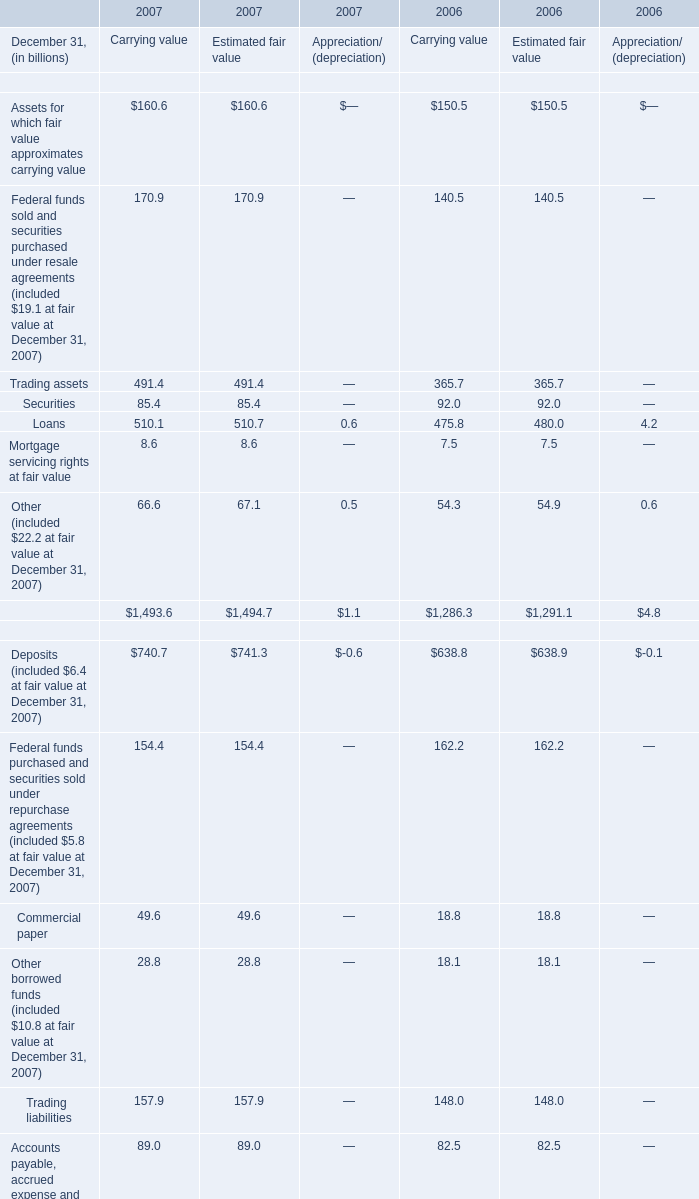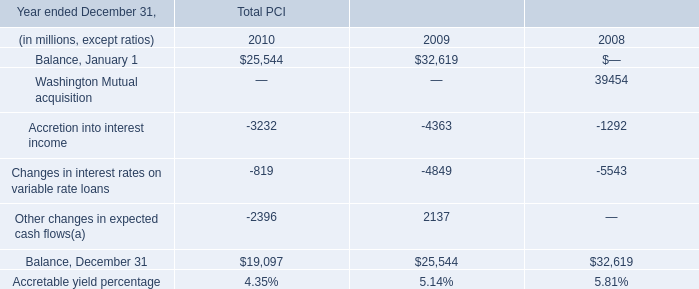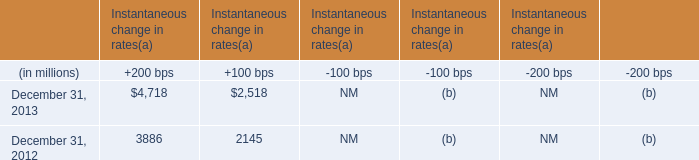What is the ratio of Trading assets for Carrying value to the total financial assets for Carrying value in 2006? 
Computations: (365.7 / 1286.3)
Answer: 0.2843. 